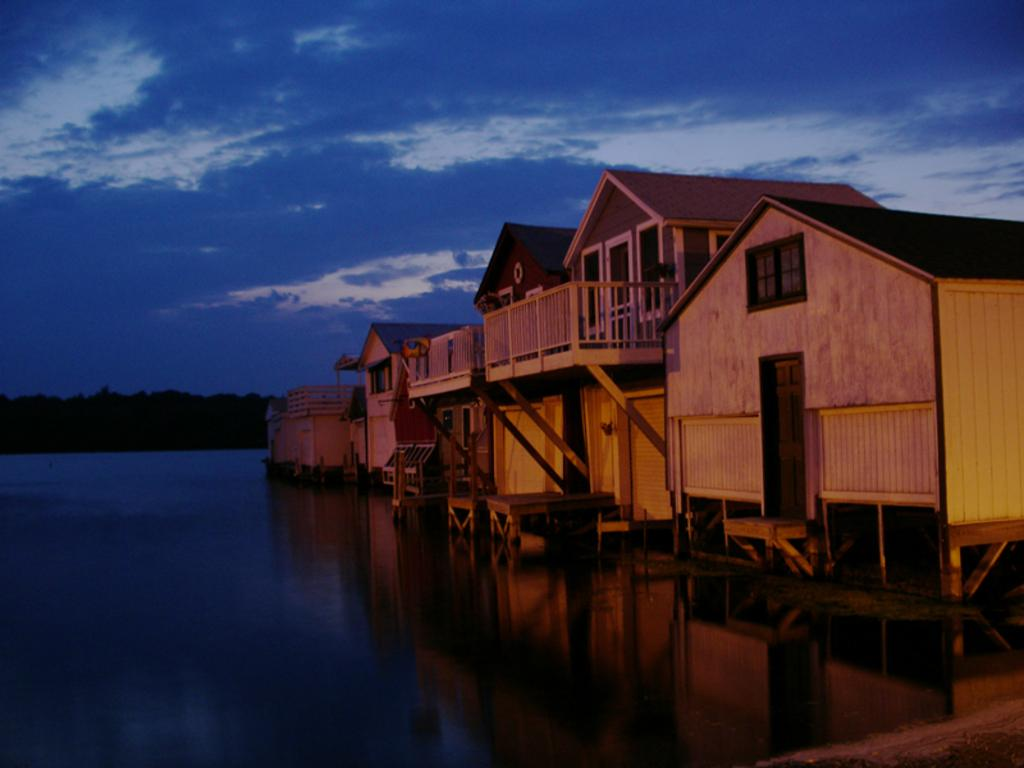What type of structures can be seen in the image? There are houses in the image. What natural element is visible in the image? There is water visible in the image. What type of vegetation can be seen in the background of the image? There are trees in the background of the image. What part of the natural environment is visible in the image? The sky is visible in the image. What can be observed in the sky in the image? Clouds are present in the sky. How much sugar is being used to sweeten the respect in the image? There is no sugar or respect present in the image; it features houses, water, trees, and clouds. 